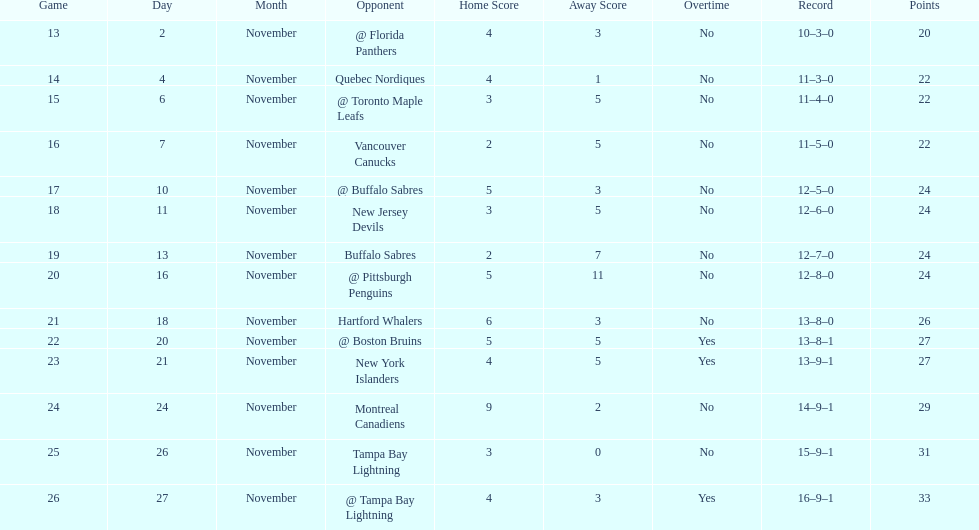What other team had the closest amount of wins? New York Islanders. 